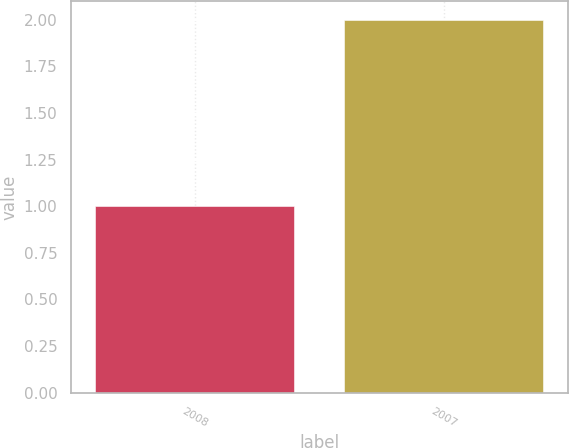Convert chart. <chart><loc_0><loc_0><loc_500><loc_500><bar_chart><fcel>2008<fcel>2007<nl><fcel>1<fcel>2<nl></chart> 